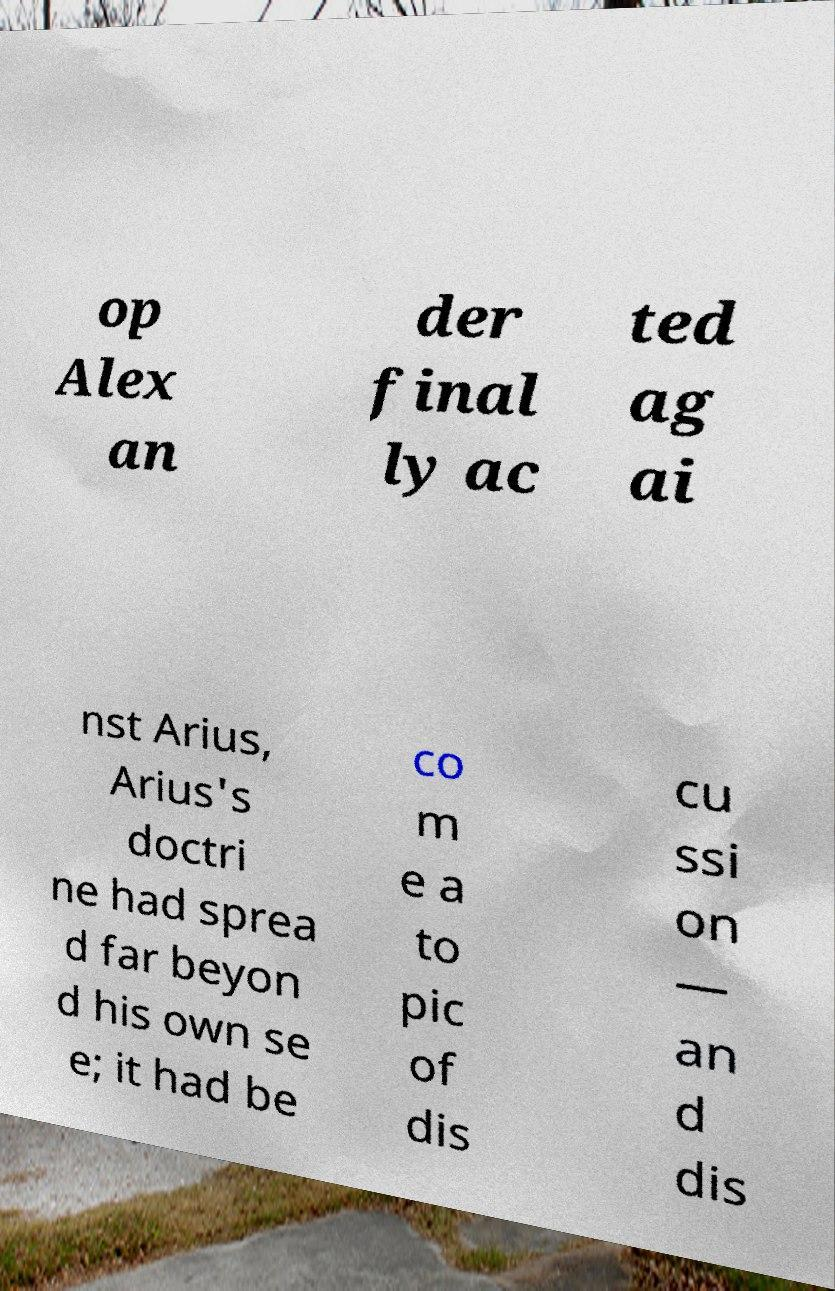There's text embedded in this image that I need extracted. Can you transcribe it verbatim? op Alex an der final ly ac ted ag ai nst Arius, Arius's doctri ne had sprea d far beyon d his own se e; it had be co m e a to pic of dis cu ssi on — an d dis 